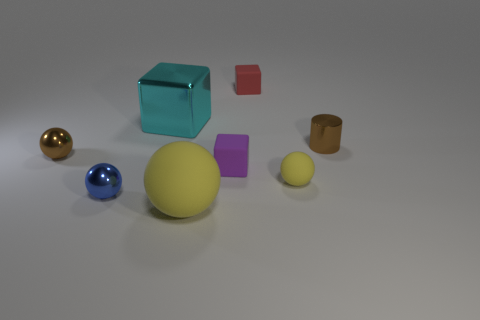Are there any big objects of the same color as the metallic block?
Offer a very short reply. No. The object that is the same size as the cyan metallic cube is what shape?
Your answer should be very brief. Sphere. Are there any small things in front of the brown metal sphere?
Offer a very short reply. Yes. Is the small brown object to the right of the brown metallic ball made of the same material as the block that is left of the big rubber sphere?
Offer a very short reply. Yes. How many other objects have the same size as the cyan metal thing?
Provide a succinct answer. 1. What is the shape of the small matte thing that is the same color as the big rubber ball?
Your response must be concise. Sphere. What is the tiny brown object that is to the right of the big metallic cube made of?
Provide a succinct answer. Metal. What number of red things have the same shape as the tiny purple matte object?
Your answer should be compact. 1. What is the shape of the purple object that is made of the same material as the red cube?
Your answer should be compact. Cube. There is a brown metal thing that is right of the tiny block that is in front of the small metallic cylinder that is right of the blue ball; what is its shape?
Offer a terse response. Cylinder. 